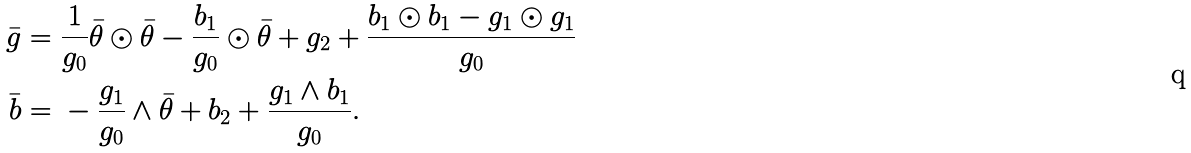<formula> <loc_0><loc_0><loc_500><loc_500>\bar { g } = & \ \frac { 1 } { g _ { 0 } } \bar { \theta } \odot \bar { \theta } - \frac { b _ { 1 } } { g _ { 0 } } \odot \bar { \theta } + g _ { 2 } + \frac { b _ { 1 } \odot b _ { 1 } - g _ { 1 } \odot g _ { 1 } } { g _ { 0 } } \\ \bar { b } = & \ - \frac { g _ { 1 } } { g _ { 0 } } \wedge \bar { \theta } + b _ { 2 } + \frac { g _ { 1 } \wedge b _ { 1 } } { g _ { 0 } } .</formula> 